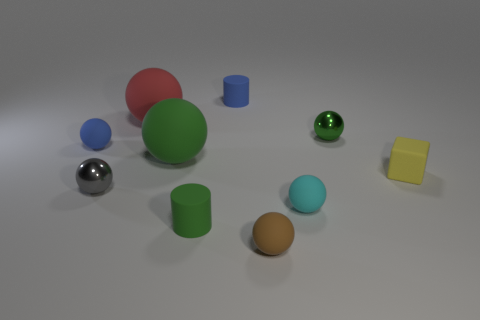There is a blue rubber object in front of the green sphere behind the small rubber sphere behind the block; what is its shape?
Ensure brevity in your answer.  Sphere. How many other things are there of the same shape as the cyan object?
Provide a short and direct response. 6. How many rubber things are either big red balls or big yellow cylinders?
Provide a succinct answer. 1. There is a small blue thing that is in front of the green object that is behind the tiny blue ball; what is its material?
Your answer should be compact. Rubber. Is the number of tiny rubber cylinders to the right of the green shiny ball greater than the number of big balls?
Your response must be concise. No. Is there a blue sphere made of the same material as the tiny green ball?
Offer a terse response. No. There is a big thing that is behind the blue rubber ball; does it have the same shape as the tiny yellow thing?
Provide a succinct answer. No. There is a small blue thing in front of the rubber cylinder that is behind the yellow block; what number of big rubber spheres are behind it?
Provide a short and direct response. 1. Are there fewer tiny blue things right of the red thing than large red spheres that are on the right side of the cyan object?
Your answer should be very brief. No. What is the color of the other big matte object that is the same shape as the red rubber object?
Provide a succinct answer. Green. 